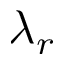Convert formula to latex. <formula><loc_0><loc_0><loc_500><loc_500>\lambda _ { r }</formula> 